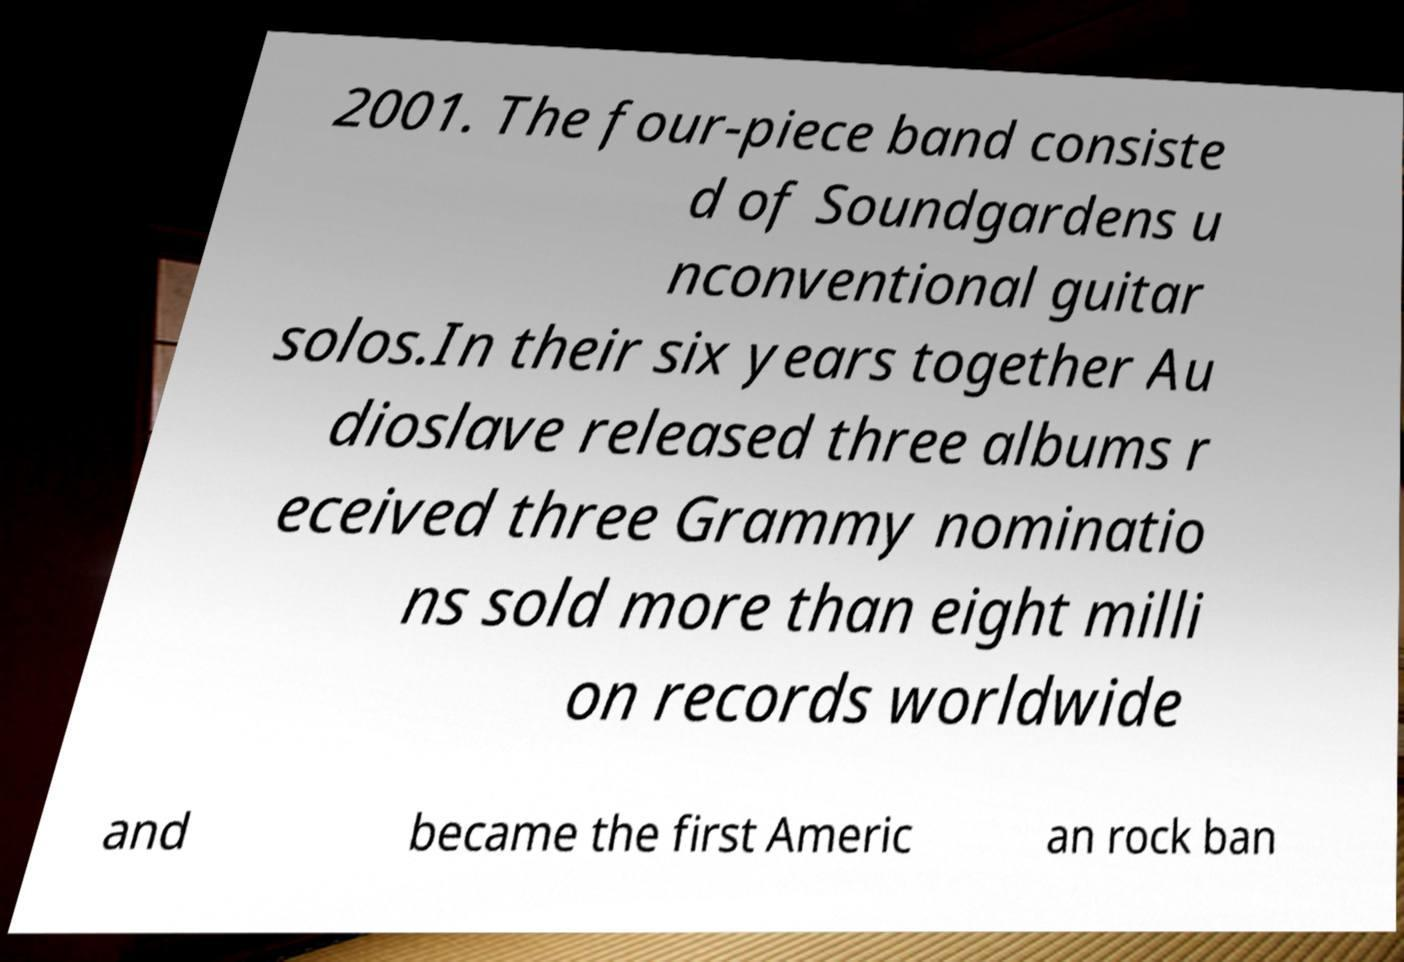Can you read and provide the text displayed in the image?This photo seems to have some interesting text. Can you extract and type it out for me? 2001. The four-piece band consiste d of Soundgardens u nconventional guitar solos.In their six years together Au dioslave released three albums r eceived three Grammy nominatio ns sold more than eight milli on records worldwide and became the first Americ an rock ban 